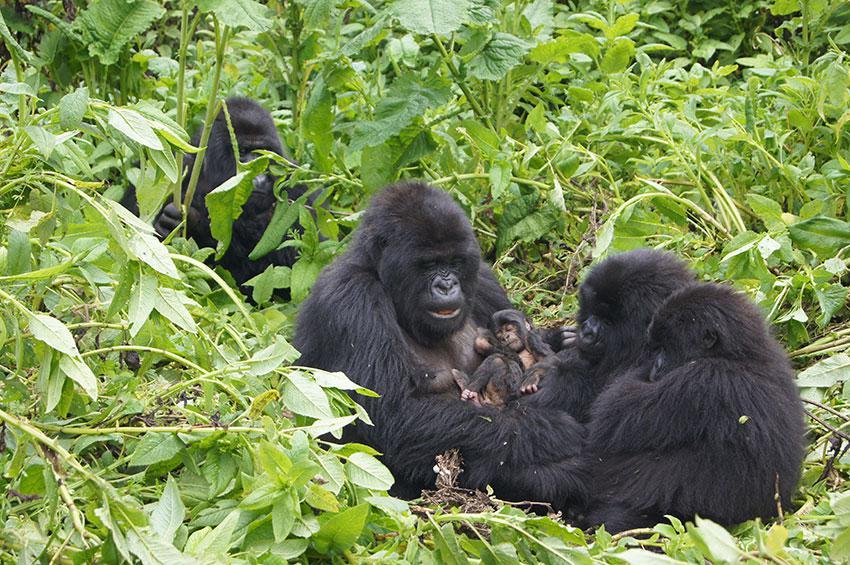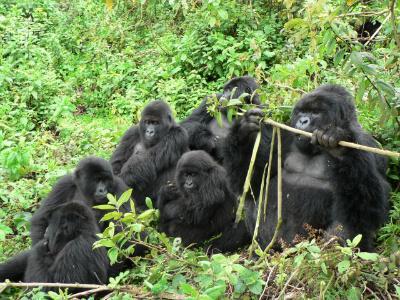The first image is the image on the left, the second image is the image on the right. Examine the images to the left and right. Is the description "One image contains at least three times the number of apes as the other image." accurate? Answer yes or no. No. The first image is the image on the left, the second image is the image on the right. Evaluate the accuracy of this statement regarding the images: "On one image, a baby gorilla is perched on a bigger gorilla.". Is it true? Answer yes or no. Yes. 